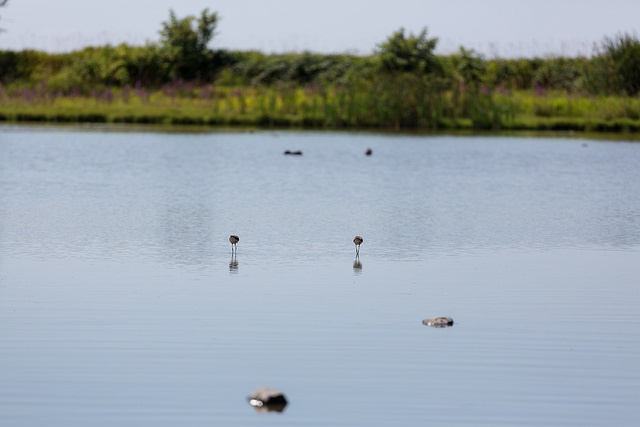Describe the objects in this image and their specific colors. I can see bird in darkgray, black, gray, and lightgray tones, bird in darkgray, gray, and black tones, bird in darkgray, gray, and black tones, bird in darkgray, gray, black, and lightgray tones, and bird in darkgray, gray, and black tones in this image. 